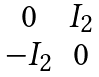<formula> <loc_0><loc_0><loc_500><loc_500>\begin{matrix} 0 & I _ { 2 } \\ - I _ { 2 } & 0 \end{matrix}</formula> 